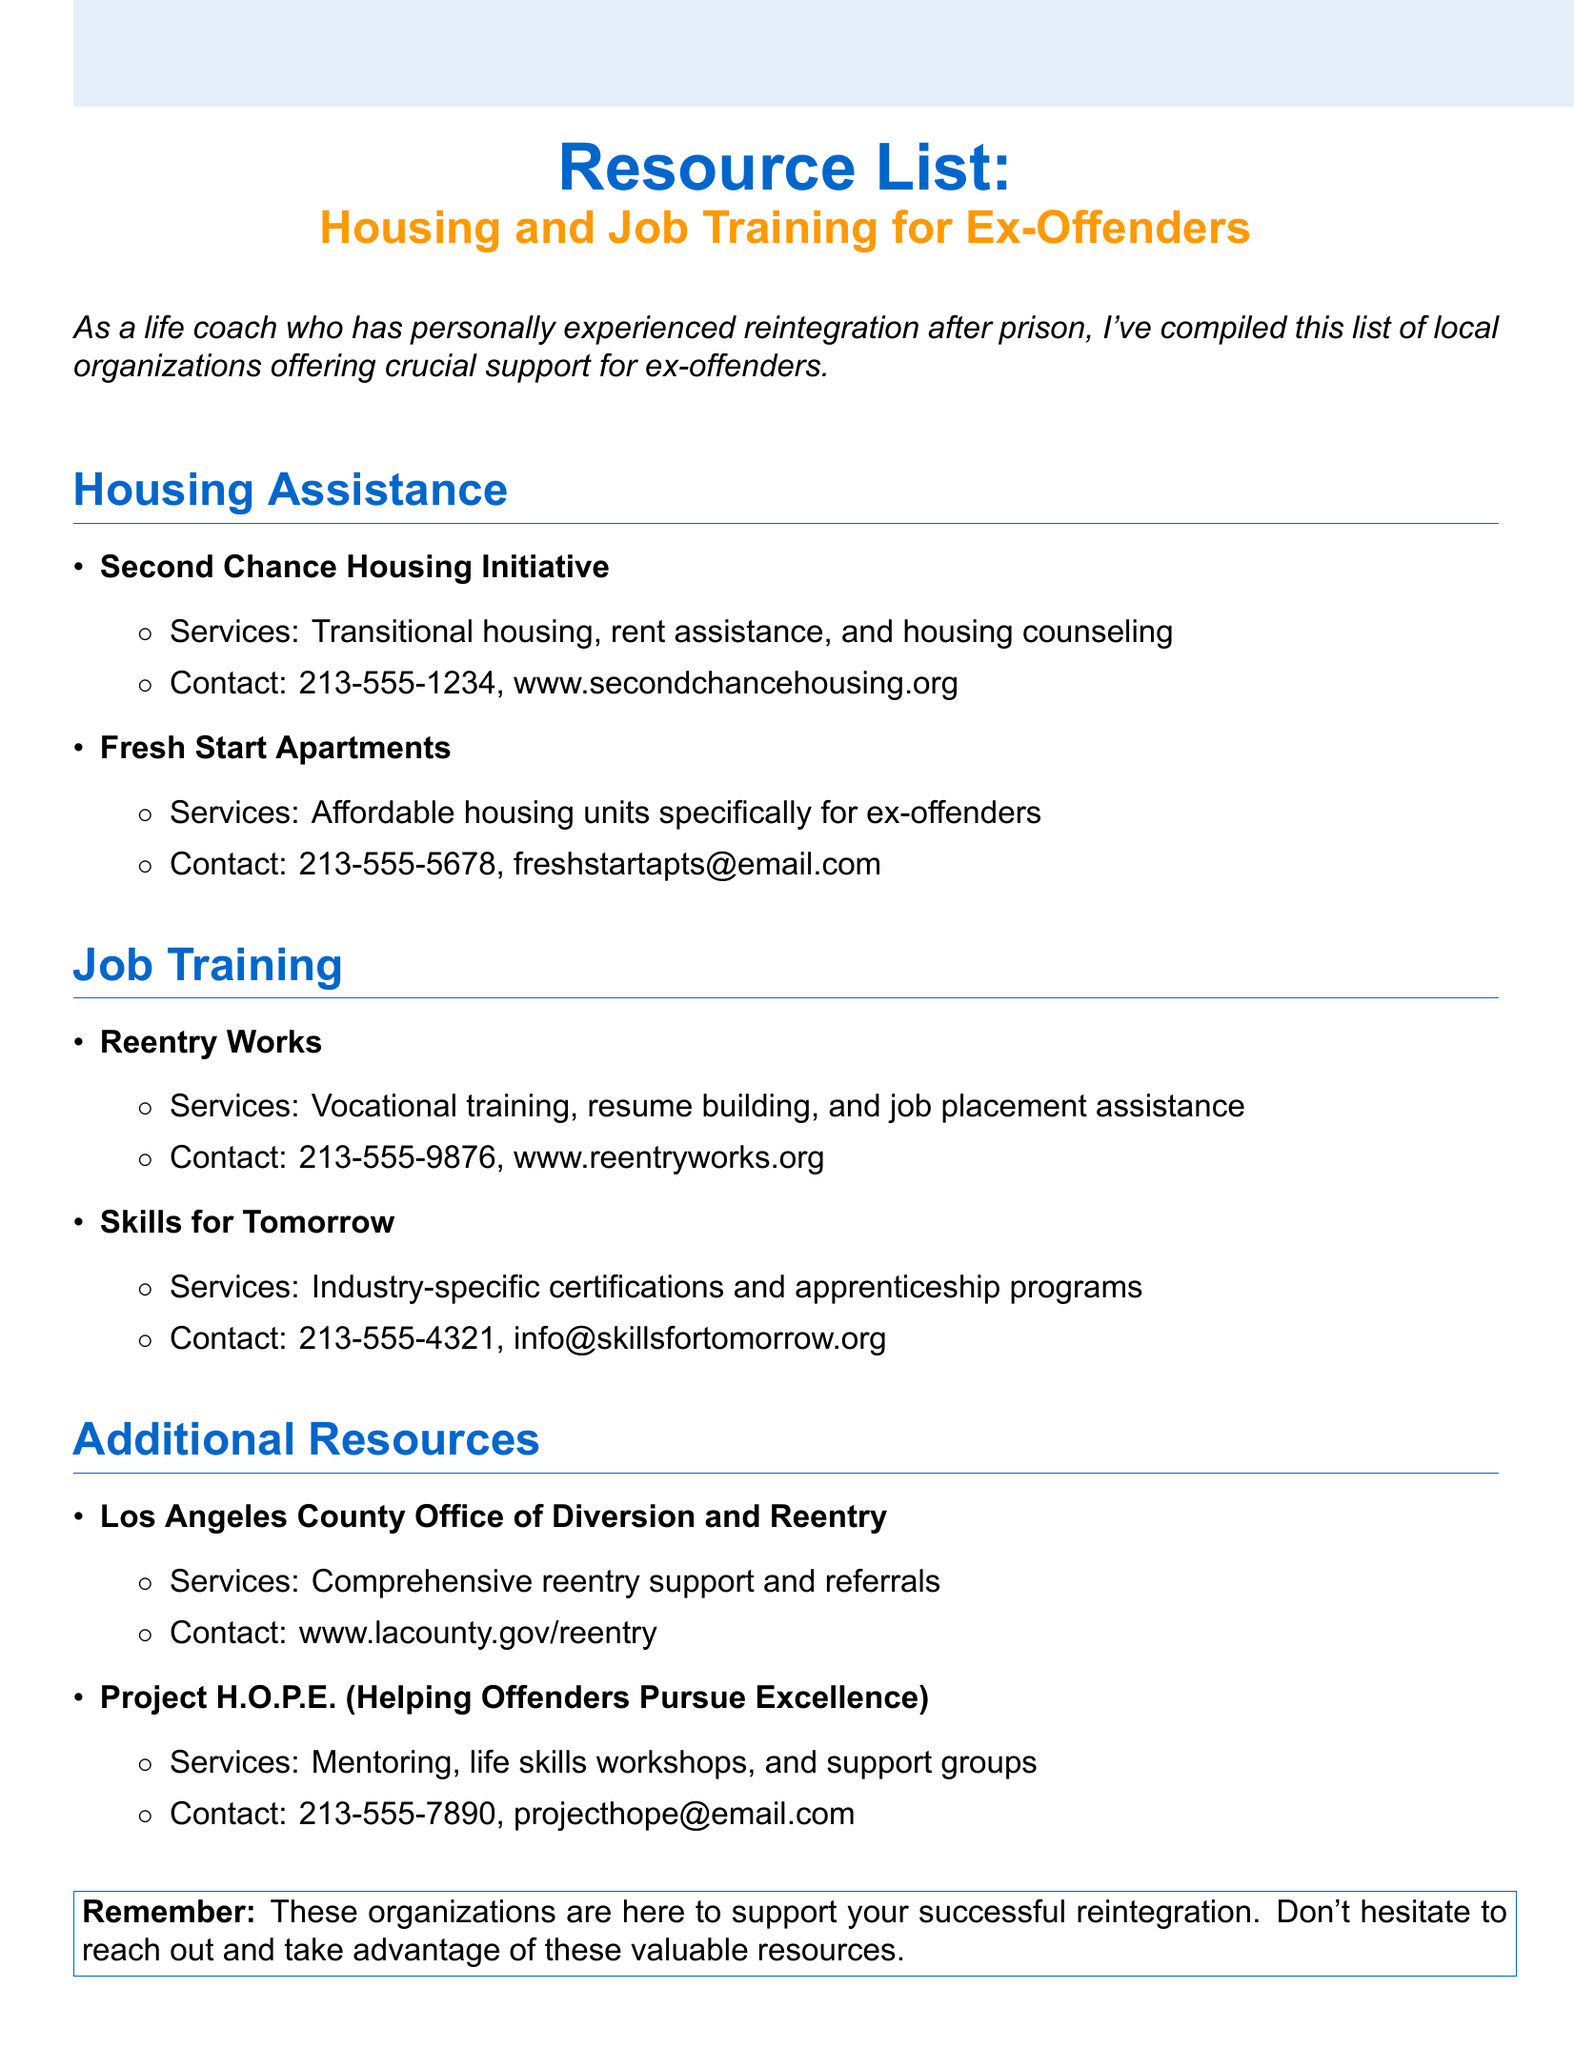What is the name of the initiative offering transitional housing? The initiative providing transitional housing is the Second Chance Housing Initiative.
Answer: Second Chance Housing Initiative What services does Fresh Start Apartments offer? Fresh Start Apartments offers affordable housing units specifically for ex-offenders.
Answer: Affordable housing units specifically for ex-offenders What type of training does Reentry Works provide? Reentry Works provides vocational training, resume building, and job placement assistance.
Answer: Vocational training, resume building, and job placement assistance What is the contact number for Skills for Tomorrow? The contact number for Skills for Tomorrow is listed in the document as 213-555-4321.
Answer: 213-555-4321 Which organization offers mentoring and life skills workshops? The organization that offers mentoring and life skills workshops is Project H.O.P.E.
Answer: Project H.O.P.E How many housing assistance organizations are listed? There are two housing assistance organizations listed in the document.
Answer: Two What organization provides comprehensive reentry support? The organization providing comprehensive reentry support is the Los Angeles County Office of Diversion and Reentry.
Answer: Los Angeles County Office of Diversion and Reentry Which section contains information about vocational training? The section containing information about vocational training is the Job Training section.
Answer: Job Training What is the main purpose of this resource list? The primary purpose of this resource list is to offer crucial support for ex-offenders.
Answer: Offer crucial support for ex-offenders 